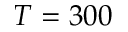<formula> <loc_0><loc_0><loc_500><loc_500>T = 3 0 0</formula> 